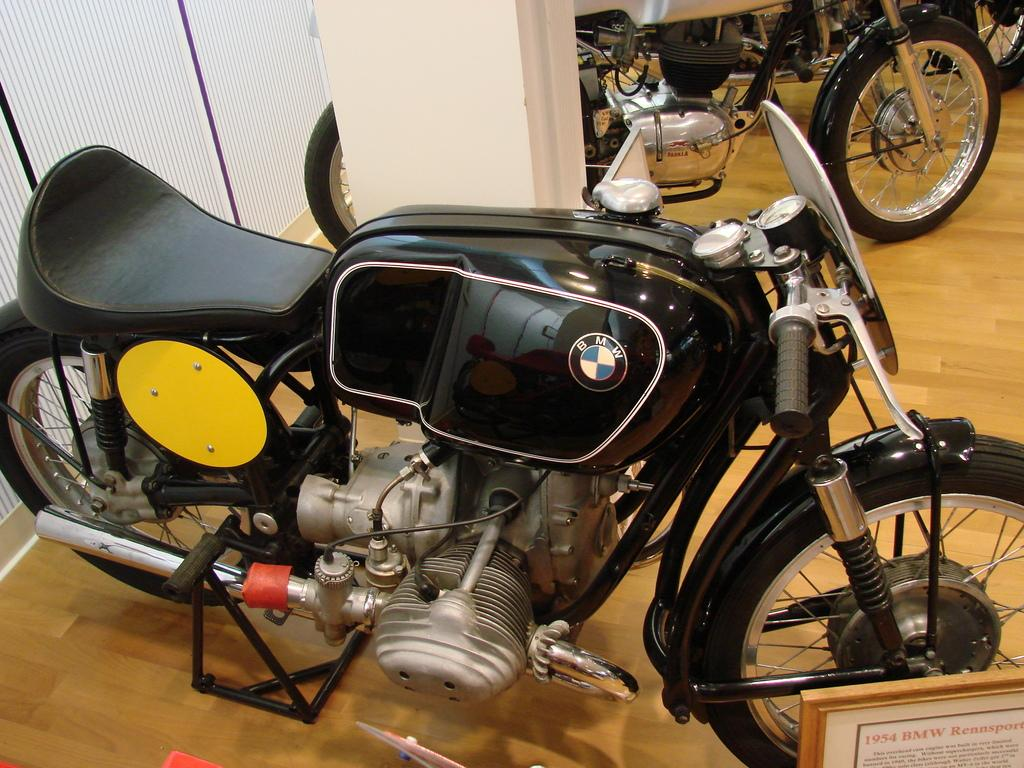What type of vehicles are in the image? There are motorcycles in the image. What is located behind the motorcycles? There is a wall behind the motorcycles. What flavor of cookies is being baked at the school in the image? There is no school or cookies present in the image; it features motorcycles and a wall. 